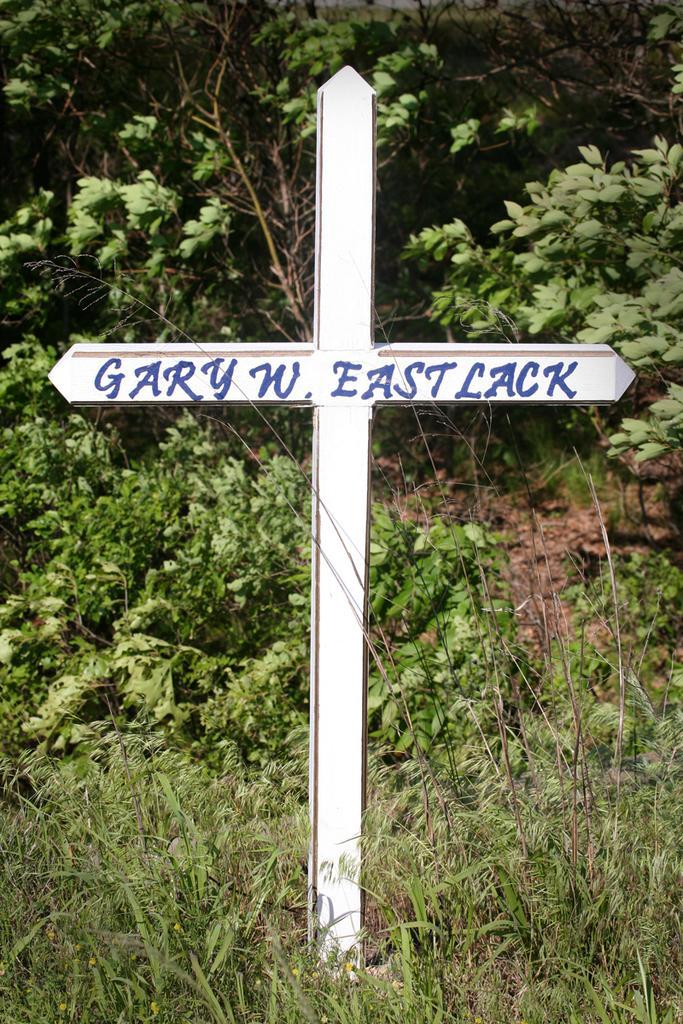Can you describe this image briefly? In the picture I can see a cross which has something written on it. In the background I can see the grass and plants. 